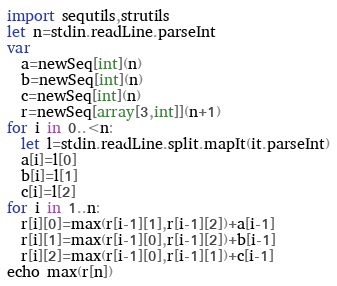Convert code to text. <code><loc_0><loc_0><loc_500><loc_500><_Nim_>import sequtils,strutils
let n=stdin.readLine.parseInt
var
  a=newSeq[int](n)
  b=newSeq[int](n)
  c=newSeq[int](n)
  r=newSeq[array[3,int]](n+1)
for i in 0..<n:
  let l=stdin.readLine.split.mapIt(it.parseInt)
  a[i]=l[0]
  b[i]=l[1]
  c[i]=l[2]
for i in 1..n:
  r[i][0]=max(r[i-1][1],r[i-1][2])+a[i-1]
  r[i][1]=max(r[i-1][0],r[i-1][2])+b[i-1]
  r[i][2]=max(r[i-1][0],r[i-1][1])+c[i-1]
echo max(r[n])
</code> 